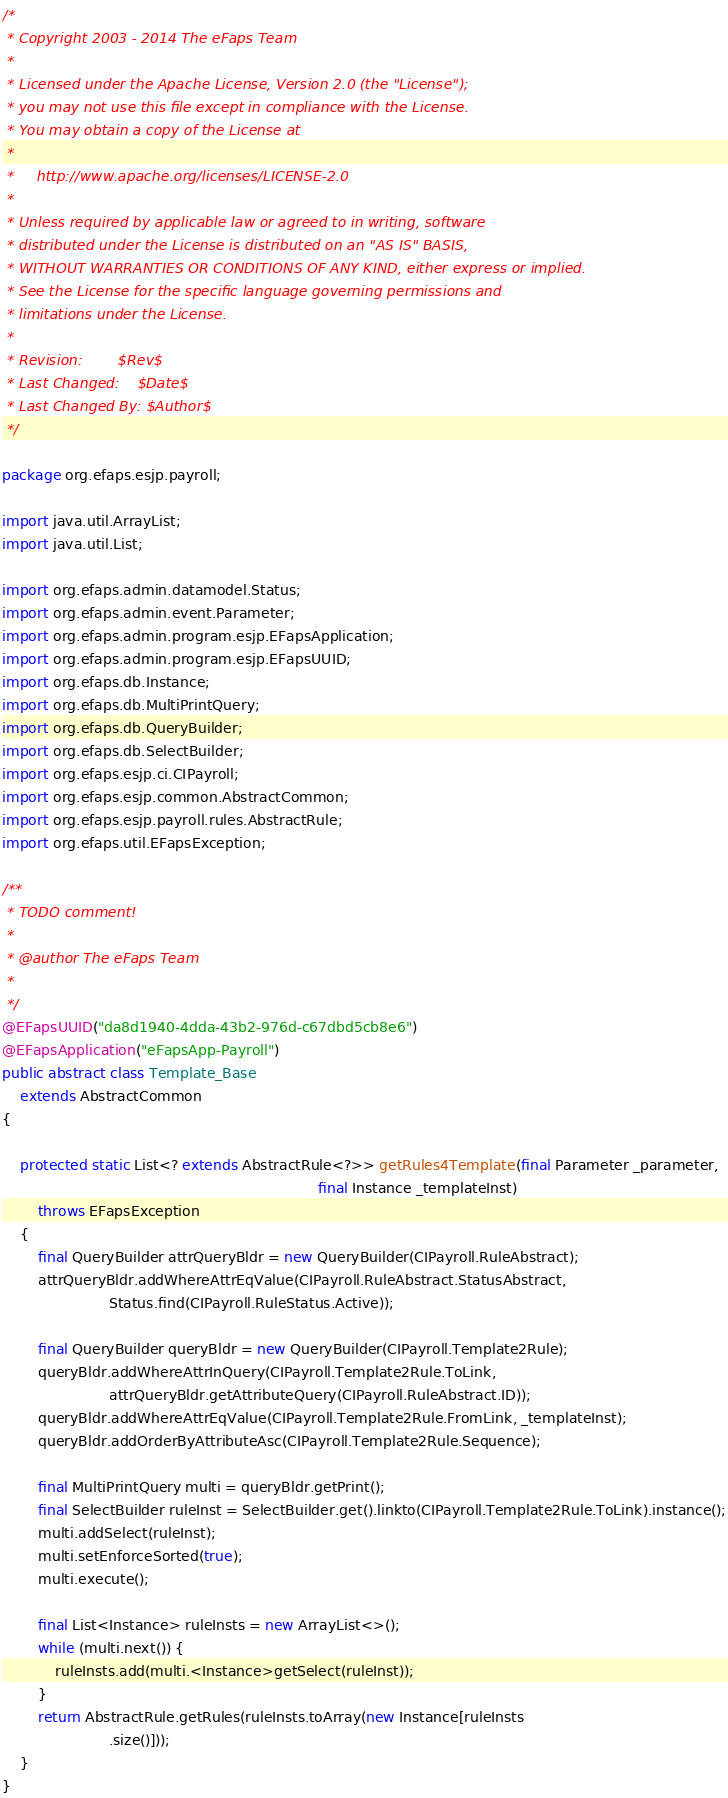Convert code to text. <code><loc_0><loc_0><loc_500><loc_500><_Java_>/*
 * Copyright 2003 - 2014 The eFaps Team
 *
 * Licensed under the Apache License, Version 2.0 (the "License");
 * you may not use this file except in compliance with the License.
 * You may obtain a copy of the License at
 *
 *     http://www.apache.org/licenses/LICENSE-2.0
 *
 * Unless required by applicable law or agreed to in writing, software
 * distributed under the License is distributed on an "AS IS" BASIS,
 * WITHOUT WARRANTIES OR CONDITIONS OF ANY KIND, either express or implied.
 * See the License for the specific language governing permissions and
 * limitations under the License.
 *
 * Revision:        $Rev$
 * Last Changed:    $Date$
 * Last Changed By: $Author$
 */

package org.efaps.esjp.payroll;

import java.util.ArrayList;
import java.util.List;

import org.efaps.admin.datamodel.Status;
import org.efaps.admin.event.Parameter;
import org.efaps.admin.program.esjp.EFapsApplication;
import org.efaps.admin.program.esjp.EFapsUUID;
import org.efaps.db.Instance;
import org.efaps.db.MultiPrintQuery;
import org.efaps.db.QueryBuilder;
import org.efaps.db.SelectBuilder;
import org.efaps.esjp.ci.CIPayroll;
import org.efaps.esjp.common.AbstractCommon;
import org.efaps.esjp.payroll.rules.AbstractRule;
import org.efaps.util.EFapsException;

/**
 * TODO comment!
 *
 * @author The eFaps Team
 * 
 */
@EFapsUUID("da8d1940-4dda-43b2-976d-c67dbd5cb8e6")
@EFapsApplication("eFapsApp-Payroll")
public abstract class Template_Base
    extends AbstractCommon
{

    protected static List<? extends AbstractRule<?>> getRules4Template(final Parameter _parameter,
                                                                       final Instance _templateInst)
        throws EFapsException
    {
        final QueryBuilder attrQueryBldr = new QueryBuilder(CIPayroll.RuleAbstract);
        attrQueryBldr.addWhereAttrEqValue(CIPayroll.RuleAbstract.StatusAbstract,
                        Status.find(CIPayroll.RuleStatus.Active));

        final QueryBuilder queryBldr = new QueryBuilder(CIPayroll.Template2Rule);
        queryBldr.addWhereAttrInQuery(CIPayroll.Template2Rule.ToLink,
                        attrQueryBldr.getAttributeQuery(CIPayroll.RuleAbstract.ID));
        queryBldr.addWhereAttrEqValue(CIPayroll.Template2Rule.FromLink, _templateInst);
        queryBldr.addOrderByAttributeAsc(CIPayroll.Template2Rule.Sequence);

        final MultiPrintQuery multi = queryBldr.getPrint();
        final SelectBuilder ruleInst = SelectBuilder.get().linkto(CIPayroll.Template2Rule.ToLink).instance();
        multi.addSelect(ruleInst);
        multi.setEnforceSorted(true);
        multi.execute();

        final List<Instance> ruleInsts = new ArrayList<>();
        while (multi.next()) {
            ruleInsts.add(multi.<Instance>getSelect(ruleInst));
        }
        return AbstractRule.getRules(ruleInsts.toArray(new Instance[ruleInsts
                        .size()]));
    }
}
</code> 